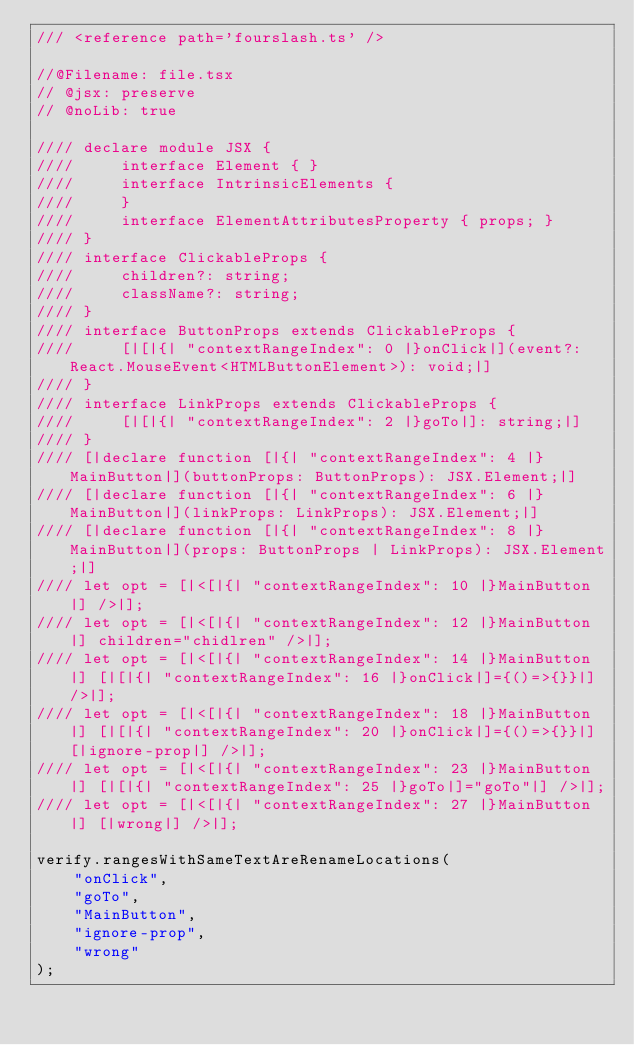<code> <loc_0><loc_0><loc_500><loc_500><_TypeScript_>/// <reference path='fourslash.ts' />

//@Filename: file.tsx
// @jsx: preserve
// @noLib: true

//// declare module JSX {
////     interface Element { }
////     interface IntrinsicElements {
////     }
////     interface ElementAttributesProperty { props; }
//// }
//// interface ClickableProps {
////     children?: string;
////     className?: string;
//// }
//// interface ButtonProps extends ClickableProps {
////     [|[|{| "contextRangeIndex": 0 |}onClick|](event?: React.MouseEvent<HTMLButtonElement>): void;|]
//// }
//// interface LinkProps extends ClickableProps {
////     [|[|{| "contextRangeIndex": 2 |}goTo|]: string;|]
//// }
//// [|declare function [|{| "contextRangeIndex": 4 |}MainButton|](buttonProps: ButtonProps): JSX.Element;|]
//// [|declare function [|{| "contextRangeIndex": 6 |}MainButton|](linkProps: LinkProps): JSX.Element;|]
//// [|declare function [|{| "contextRangeIndex": 8 |}MainButton|](props: ButtonProps | LinkProps): JSX.Element;|]
//// let opt = [|<[|{| "contextRangeIndex": 10 |}MainButton|] />|];
//// let opt = [|<[|{| "contextRangeIndex": 12 |}MainButton|] children="chidlren" />|];
//// let opt = [|<[|{| "contextRangeIndex": 14 |}MainButton|] [|[|{| "contextRangeIndex": 16 |}onClick|]={()=>{}}|] />|];
//// let opt = [|<[|{| "contextRangeIndex": 18 |}MainButton|] [|[|{| "contextRangeIndex": 20 |}onClick|]={()=>{}}|] [|ignore-prop|] />|];
//// let opt = [|<[|{| "contextRangeIndex": 23 |}MainButton|] [|[|{| "contextRangeIndex": 25 |}goTo|]="goTo"|] />|];
//// let opt = [|<[|{| "contextRangeIndex": 27 |}MainButton|] [|wrong|] />|];

verify.rangesWithSameTextAreRenameLocations(
    "onClick",
    "goTo",
    "MainButton",
    "ignore-prop",
    "wrong"
);</code> 